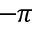<formula> <loc_0><loc_0><loc_500><loc_500>- \pi</formula> 